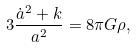<formula> <loc_0><loc_0><loc_500><loc_500>3 \frac { \dot { a } ^ { 2 } + k } { a ^ { 2 } } = 8 \pi G \rho ,</formula> 